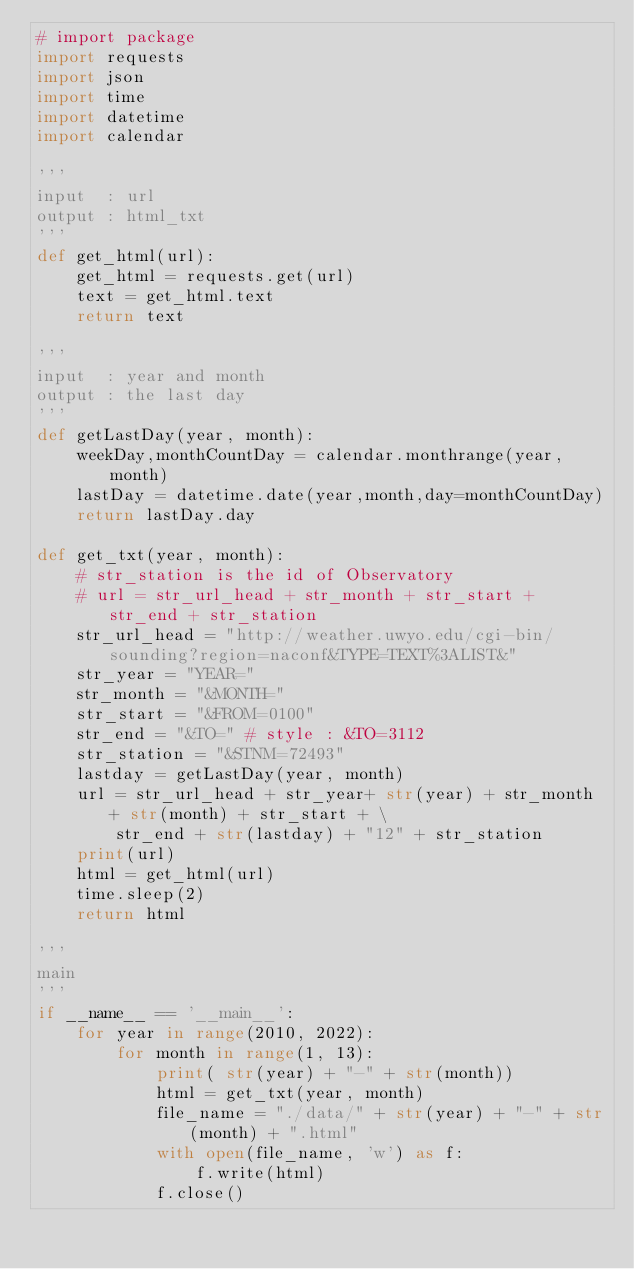<code> <loc_0><loc_0><loc_500><loc_500><_Python_># import package
import requests
import json
import time
import datetime
import calendar

'''
input  : url
output : html_txt 
'''
def get_html(url):
    get_html = requests.get(url)
    text = get_html.text
    return text

'''
input  : year and month
output : the last day
'''
def getLastDay(year, month):
    weekDay,monthCountDay = calendar.monthrange(year,month)
    lastDay = datetime.date(year,month,day=monthCountDay)
    return lastDay.day

def get_txt(year, month):
    # str_station is the id of Observatory 
    # url = str_url_head + str_month + str_start + str_end + str_station
    str_url_head = "http://weather.uwyo.edu/cgi-bin/sounding?region=naconf&TYPE=TEXT%3ALIST&"
    str_year = "YEAR="
    str_month = "&MONTH="
    str_start = "&FROM=0100" 
    str_end = "&TO=" # style : &TO=3112
    str_station = "&STNM=72493"
    lastday = getLastDay(year, month)
    url = str_url_head + str_year+ str(year) + str_month + str(month) + str_start + \
        str_end + str(lastday) + "12" + str_station
    print(url)
    html = get_html(url)
    time.sleep(2)
    return html

'''
main
'''
if __name__ == '__main__':
    for year in range(2010, 2022):
        for month in range(1, 13):
            print( str(year) + "-" + str(month))
            html = get_txt(year, month)
            file_name = "./data/" + str(year) + "-" + str(month) + ".html"
            with open(file_name, 'w') as f:
                f.write(html)
            f.close()</code> 